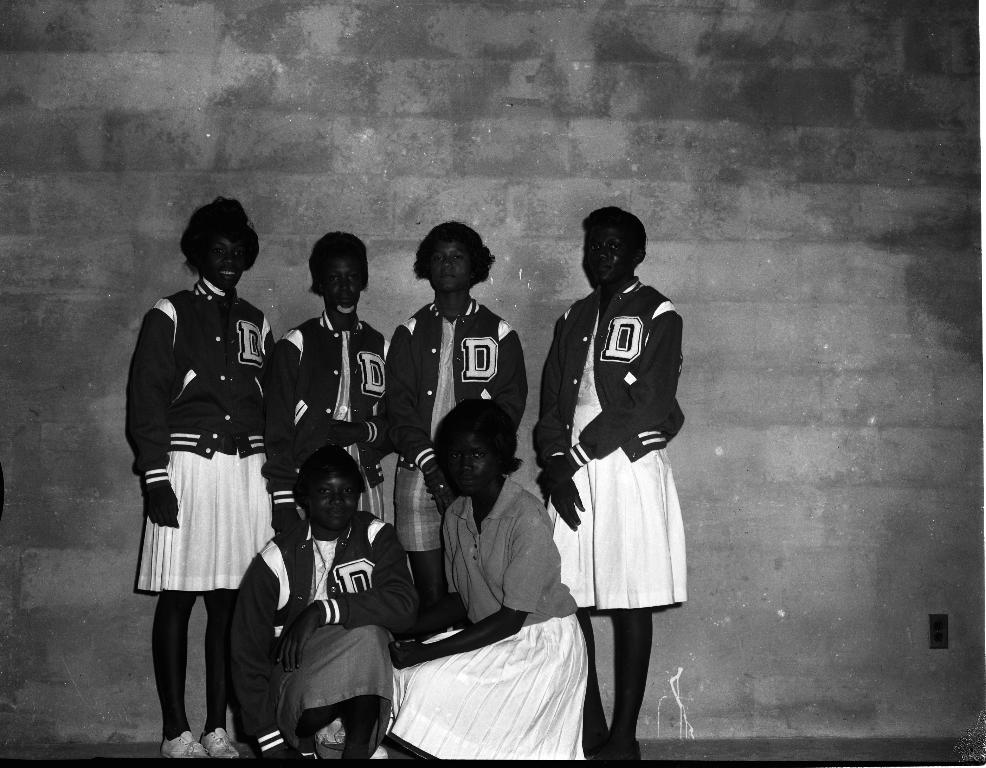How many people are present in the image? There are six persons in the image. What can be seen in the background of the image? There is a wall in the background of the image. Is there a volcano erupting in the background of the image? No, there is no volcano present in the image. What type of cream is being served to the persons in the image? There is no cream visible in the image; it only features six persons and a wall in the background. 